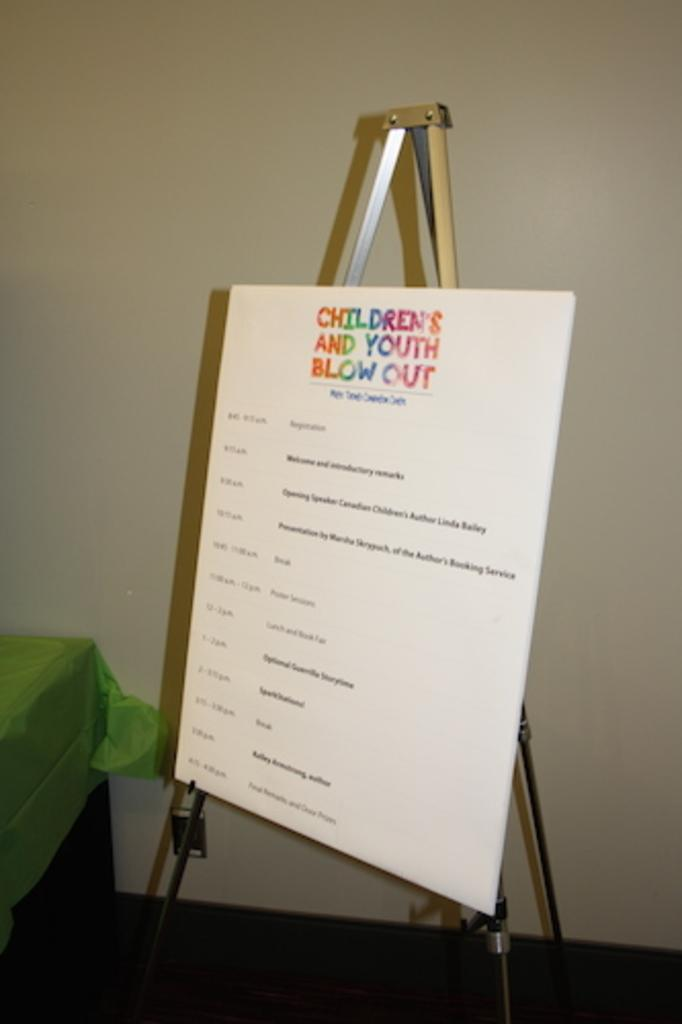<image>
Create a compact narrative representing the image presented. An easel with a large poster board on it, poster board has Children's and Youth Blow Outs in multi colors. 